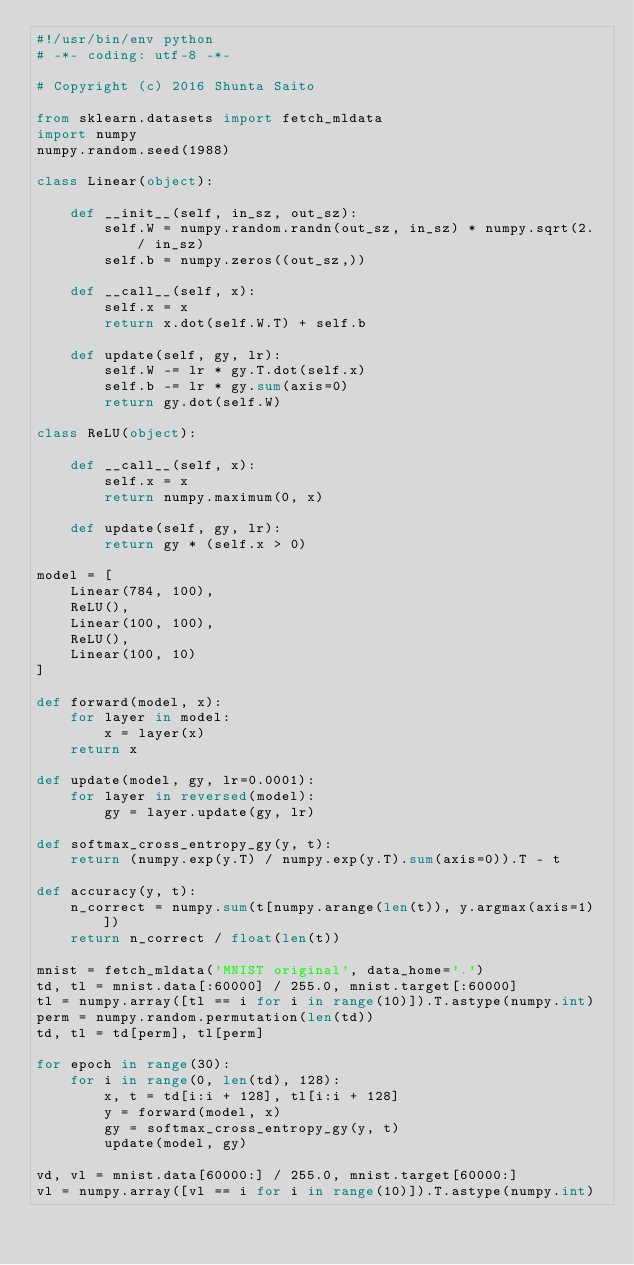<code> <loc_0><loc_0><loc_500><loc_500><_Python_>#!/usr/bin/env python
# -*- coding: utf-8 -*-

# Copyright (c) 2016 Shunta Saito

from sklearn.datasets import fetch_mldata
import numpy
numpy.random.seed(1988)

class Linear(object):

    def __init__(self, in_sz, out_sz):
        self.W = numpy.random.randn(out_sz, in_sz) * numpy.sqrt(2. / in_sz)
        self.b = numpy.zeros((out_sz,))

    def __call__(self, x):
        self.x = x
        return x.dot(self.W.T) + self.b

    def update(self, gy, lr):
        self.W -= lr * gy.T.dot(self.x)
        self.b -= lr * gy.sum(axis=0)
        return gy.dot(self.W)

class ReLU(object):

    def __call__(self, x):
        self.x = x
        return numpy.maximum(0, x)

    def update(self, gy, lr):
        return gy * (self.x > 0)

model = [
    Linear(784, 100),
    ReLU(),
    Linear(100, 100),
    ReLU(),
    Linear(100, 10)
]

def forward(model, x):
    for layer in model:
        x = layer(x)
    return x

def update(model, gy, lr=0.0001):
    for layer in reversed(model):
        gy = layer.update(gy, lr)

def softmax_cross_entropy_gy(y, t):
    return (numpy.exp(y.T) / numpy.exp(y.T).sum(axis=0)).T - t

def accuracy(y, t):
    n_correct = numpy.sum(t[numpy.arange(len(t)), y.argmax(axis=1)])
    return n_correct / float(len(t))

mnist = fetch_mldata('MNIST original', data_home='.')
td, tl = mnist.data[:60000] / 255.0, mnist.target[:60000]
tl = numpy.array([tl == i for i in range(10)]).T.astype(numpy.int)
perm = numpy.random.permutation(len(td))
td, tl = td[perm], tl[perm]

for epoch in range(30):
    for i in range(0, len(td), 128):
        x, t = td[i:i + 128], tl[i:i + 128]
        y = forward(model, x)
        gy = softmax_cross_entropy_gy(y, t)
        update(model, gy)

vd, vl = mnist.data[60000:] / 255.0, mnist.target[60000:]
vl = numpy.array([vl == i for i in range(10)]).T.astype(numpy.int)</code> 